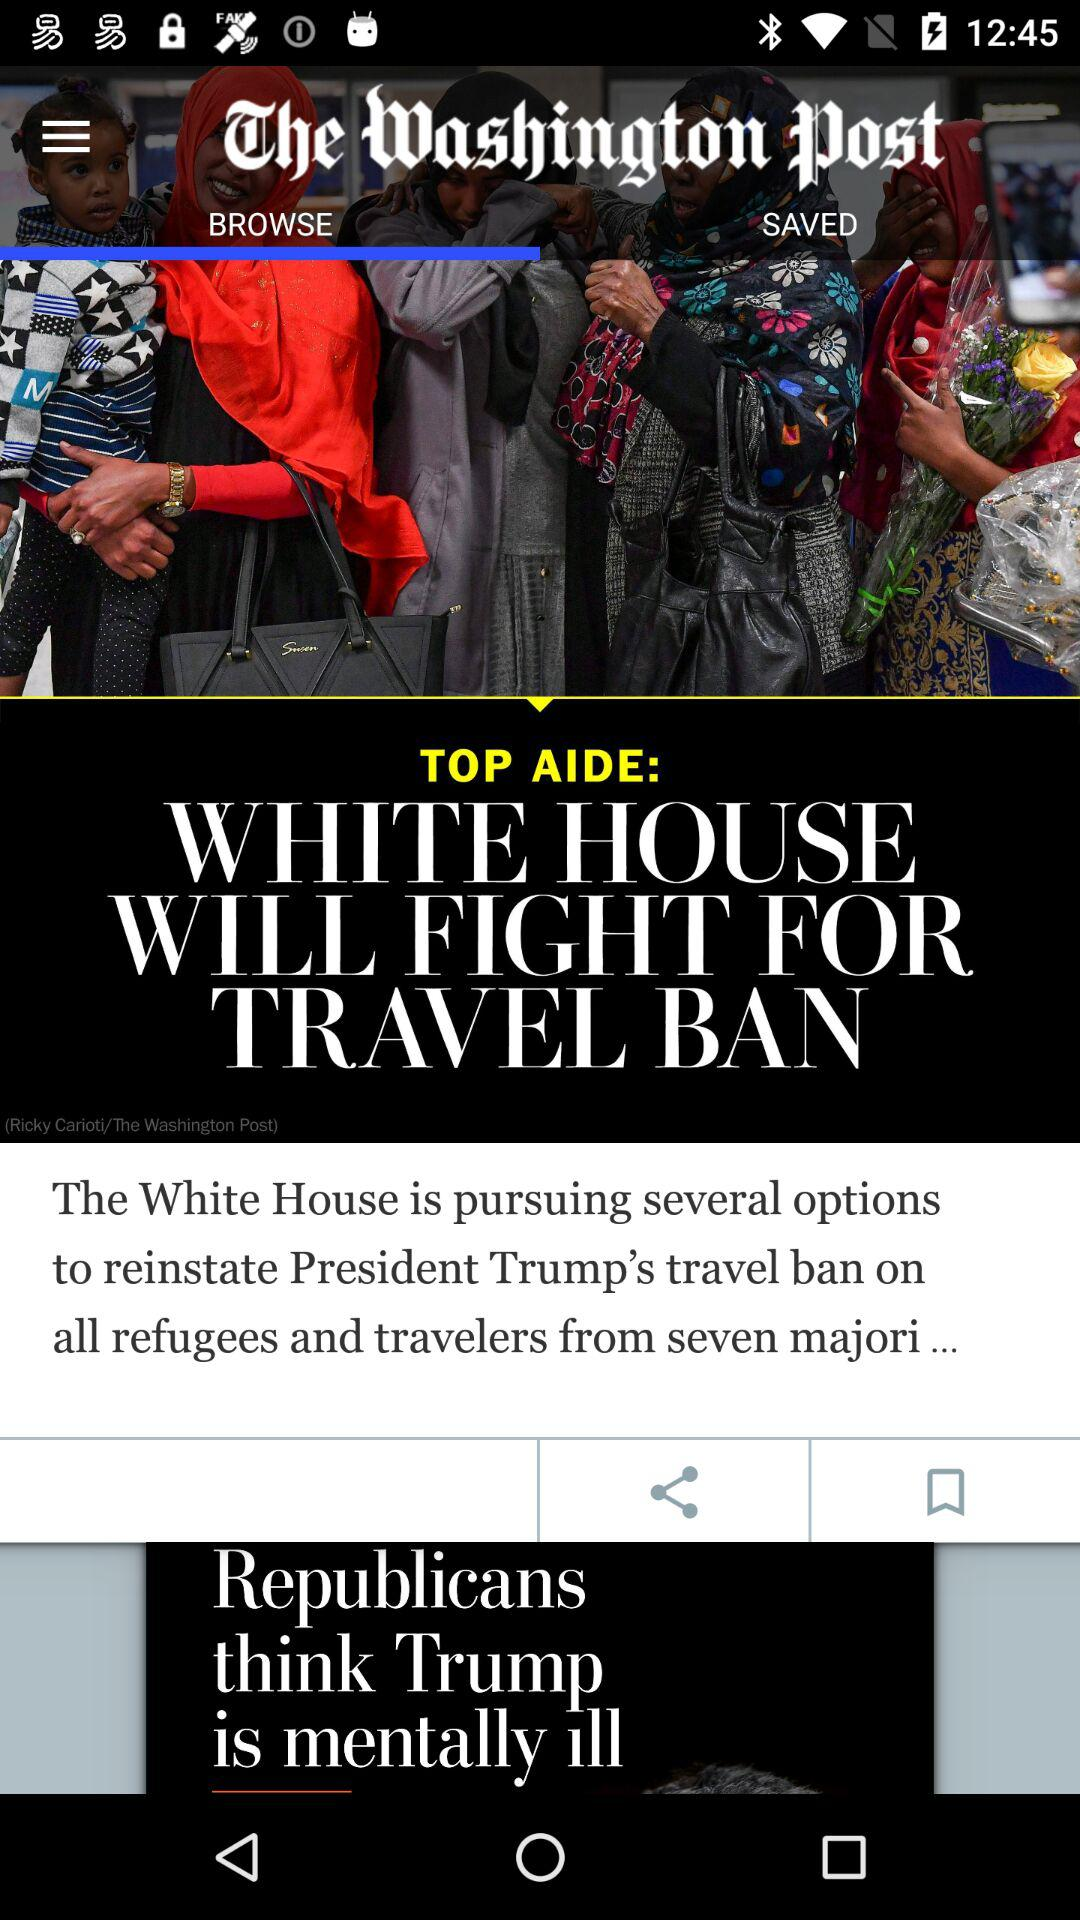Which articles are saved?
When the provided information is insufficient, respond with <no answer>. <no answer> 